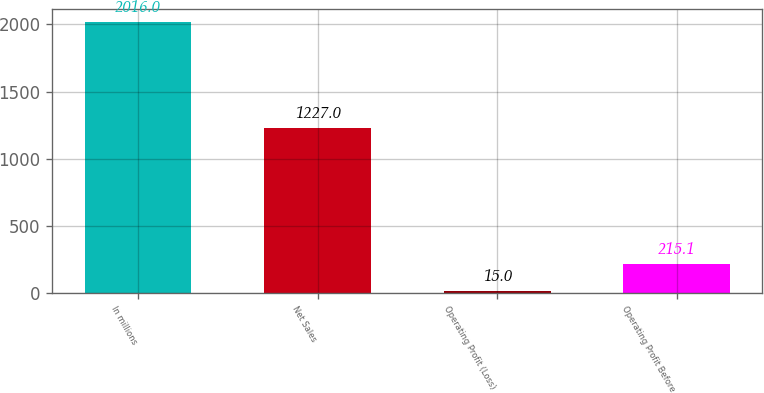Convert chart to OTSL. <chart><loc_0><loc_0><loc_500><loc_500><bar_chart><fcel>In millions<fcel>Net Sales<fcel>Operating Profit (Loss)<fcel>Operating Profit Before<nl><fcel>2016<fcel>1227<fcel>15<fcel>215.1<nl></chart> 